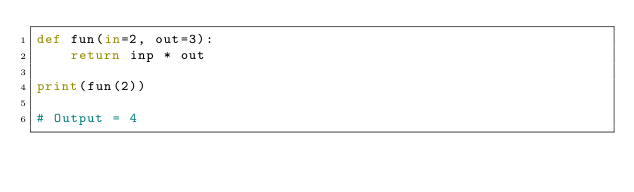Convert code to text. <code><loc_0><loc_0><loc_500><loc_500><_Python_>def fun(in=2, out=3):
    return inp * out

print(fun(2))

# Output = 4</code> 